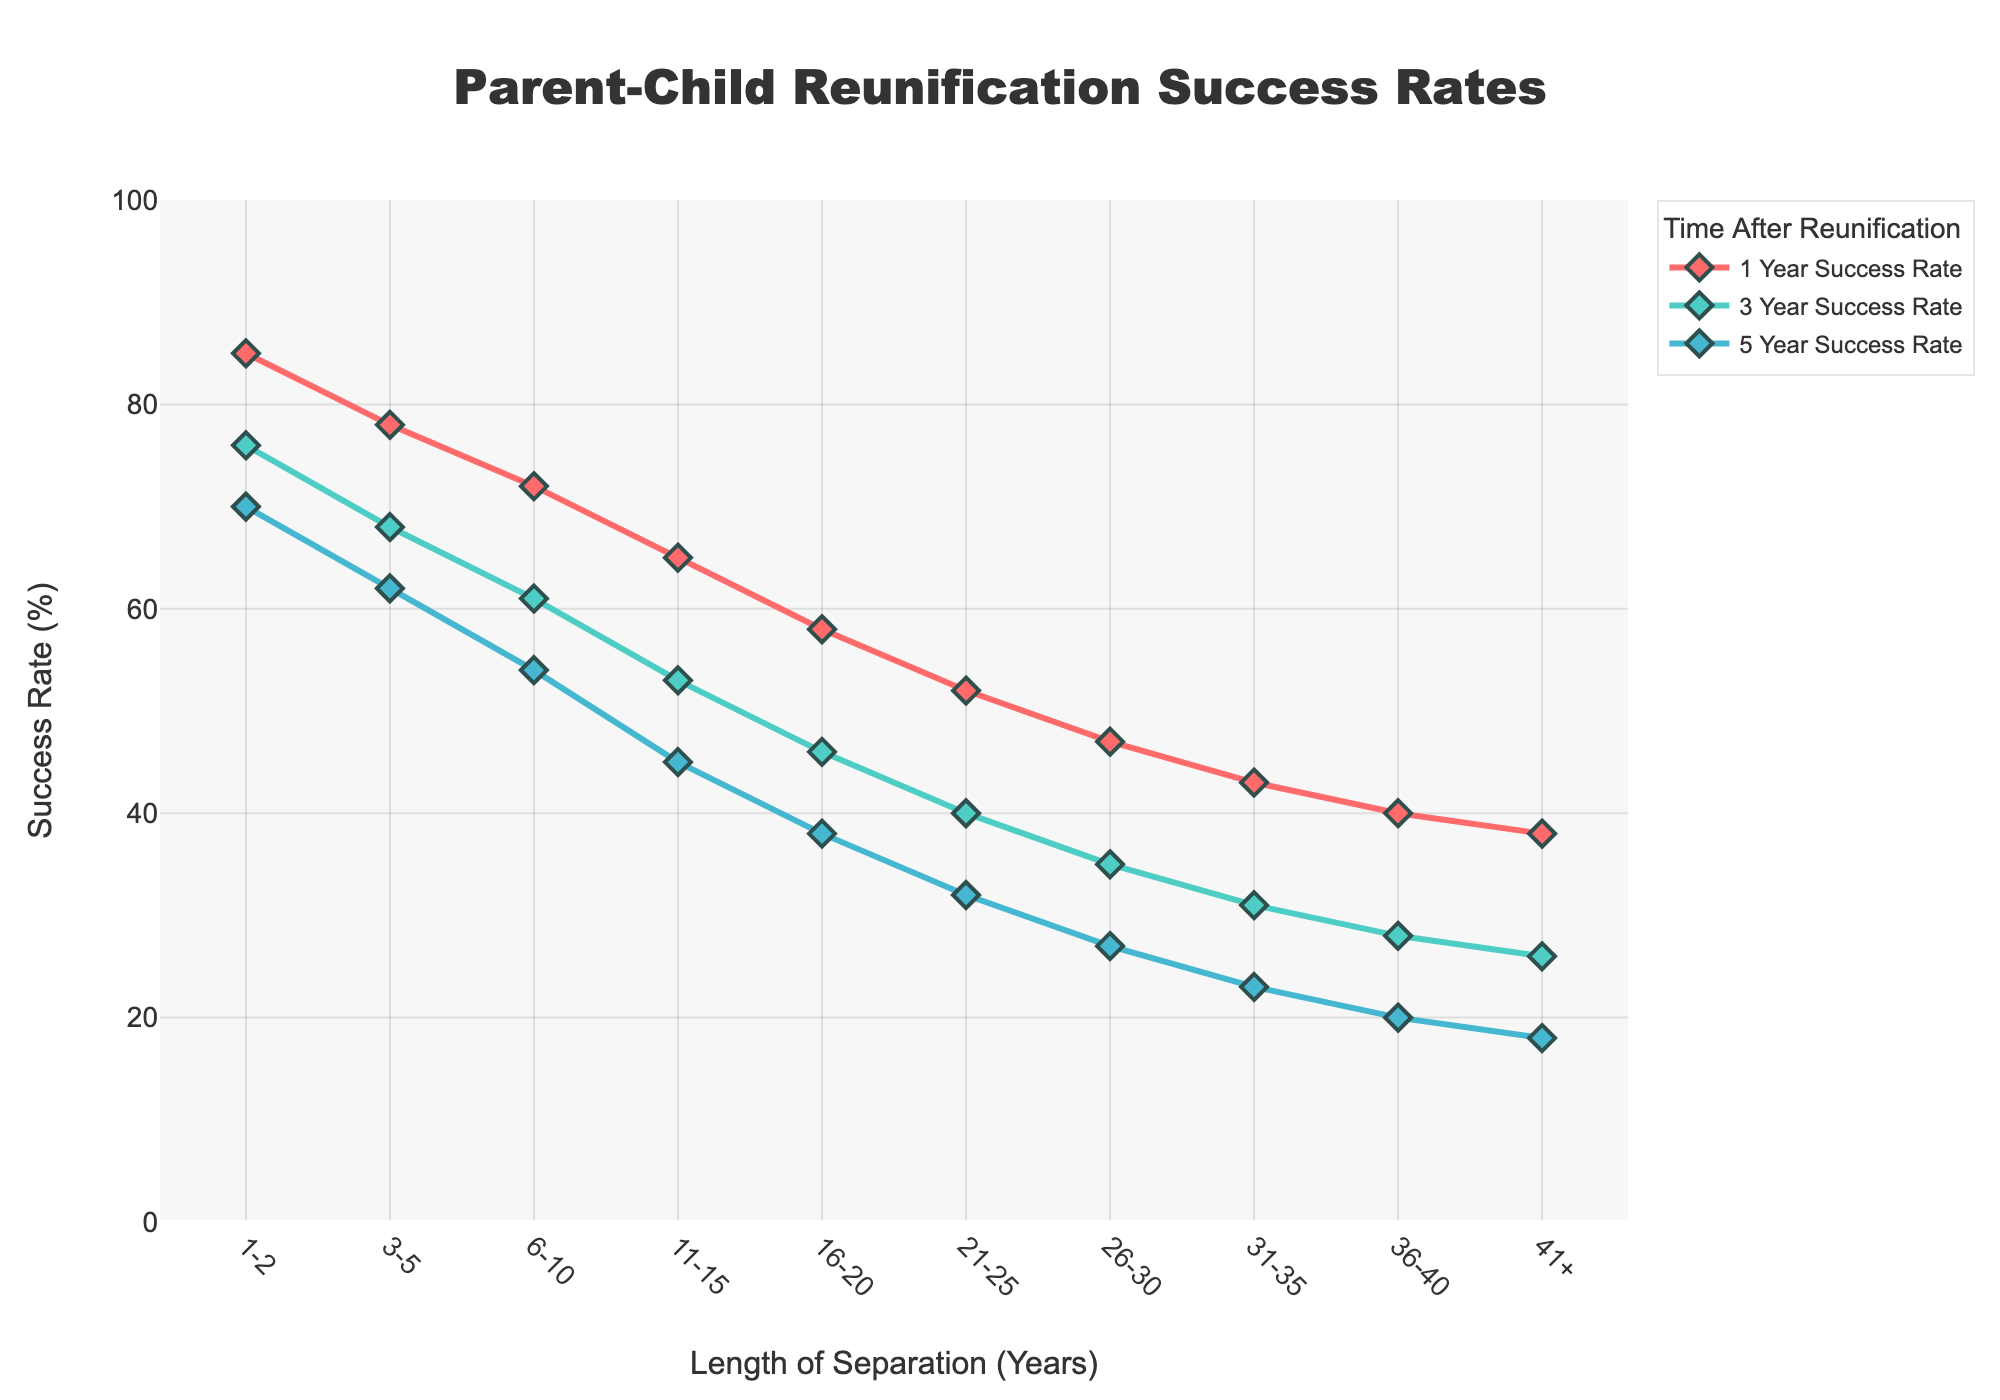What is the success rate for reunification after 1 year of separation for the group with 1-2 years of separation? Look at the red line representing the 1 Year Success Rate and find the corresponding value for the group with 1-2 years of separation. The value is 85%.
Answer: 85% Which group shows the highest success rate after 5 years of separation? Look at the blue line representing the 5 Year Success Rate and identify the group with the highest value. The group with 1-2 years of separation shows the highest success rate, which is 70%.
Answer: 1-2 years How much does the 3 Year Success Rate decline from the group with 1-2 years of separation to the group with 6-10 years of separation? Look at the green line representing the 3 Year Success Rate. For the group with 1-2 years of separation, the rate is 76%. For the group with 6-10 years of separation, it is 61%. The decline is 76% - 61% = 15%.
Answer: 15% Which group has a success rate (3 Year Success Rate) closest to 50%? Look at the green line representing the 3 Year Success Rate and identify the group whose value is closest to 50%. The group with 11-15 years of separation has a rate of 53%, which is closest to 50%.
Answer: 11-15 years For which length of separation does the 1 Year Success Rate first drop below 50%? Look at the red line representing the 1 Year Success Rate and find the first point where the rate is below 50%. The rate first drops below 50% for the group with 21-25 years of separation.
Answer: 21-25 years What is the average success rate after 1 year for all the groups? Add the success rates for all groups in the red line (1 Year Success Rate) and divide by the number of groups. The sum is 85 + 78 + 72 + 65 + 58 + 52 + 47 + 43 + 40 + 38 = 578. There are 10 groups, so the average is 578 / 10 = 57.8%.
Answer: 57.8% Compare the 5 Year Success Rate for the groups with 11-15 years and 26-30 years of separation. Which group has a higher success rate? Look at the blue line representing the 5 Year Success Rate. The group with 11-15 years of separation has a rate of 45%, while the group with 26-30 years of separation has a rate of 27%. The group with 11-15 years of separation has a higher success rate.
Answer: 11-15 years By how much does the success rate decrease from 1 Year to 5 Year for the group with 16-20 years of separation? Look at the values for the group with 16-20 years of separation. The 1 Year Success Rate is 58%, and the 5 Year Success Rate is 38%. The decrease is 58% - 38% = 20%.
Answer: 20% Which color represents the 3 Year Success Rate in the chart? Look at the legend in the chart to identify the color corresponding to the 3 Year Success Rate. It is represented by the green color in the line chart.
Answer: Green What is the difference in the 1 Year Success Rate between the groups with 1-2 years and 3-5 years of separation? Look at the red line representing the 1 Year Success Rate. The rate for the group with 1-2 years is 85%, and for 3-5 years, it is 78%. The difference is 85% - 78% = 7%.
Answer: 7% 